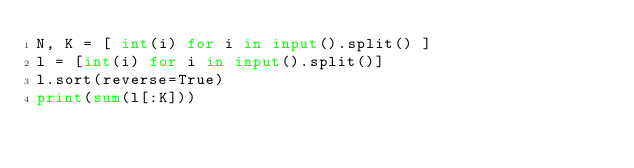<code> <loc_0><loc_0><loc_500><loc_500><_Python_>N, K = [ int(i) for i in input().split() ]
l = [int(i) for i in input().split()]
l.sort(reverse=True)
print(sum(l[:K]))</code> 